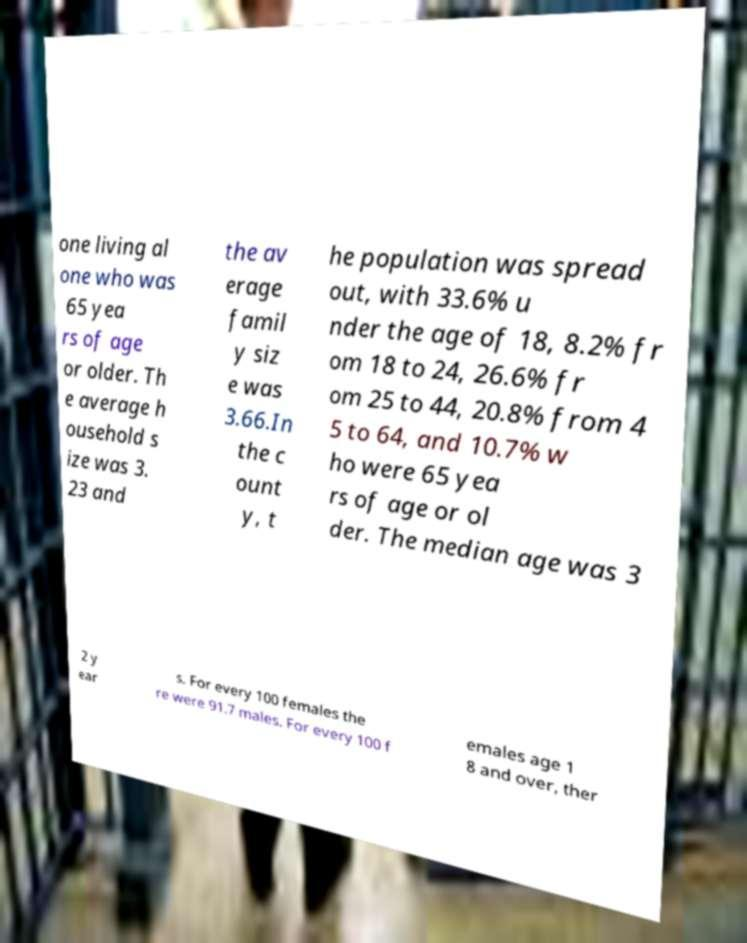What messages or text are displayed in this image? I need them in a readable, typed format. one living al one who was 65 yea rs of age or older. Th e average h ousehold s ize was 3. 23 and the av erage famil y siz e was 3.66.In the c ount y, t he population was spread out, with 33.6% u nder the age of 18, 8.2% fr om 18 to 24, 26.6% fr om 25 to 44, 20.8% from 4 5 to 64, and 10.7% w ho were 65 yea rs of age or ol der. The median age was 3 2 y ear s. For every 100 females the re were 91.7 males. For every 100 f emales age 1 8 and over, ther 